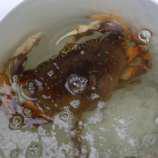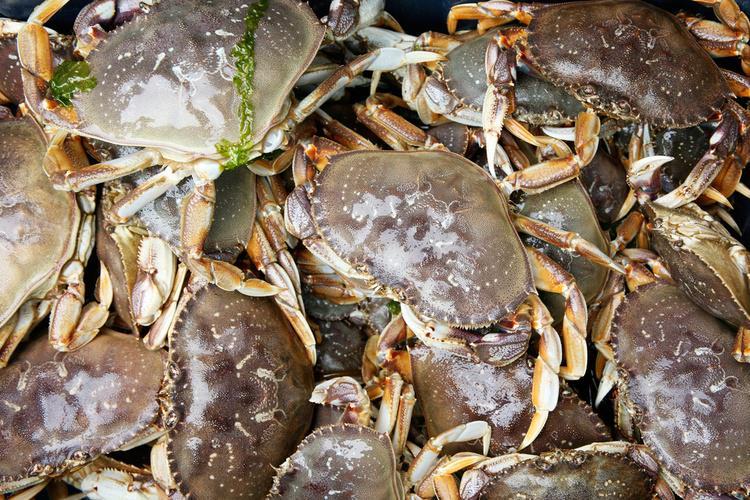The first image is the image on the left, the second image is the image on the right. Given the left and right images, does the statement "One of the images features exactly one crab." hold true? Answer yes or no. Yes. The first image is the image on the left, the second image is the image on the right. Analyze the images presented: Is the assertion "One image features one prominent forward-facing purple crab, and the other image features multiple crabs in a top-view." valid? Answer yes or no. No. 